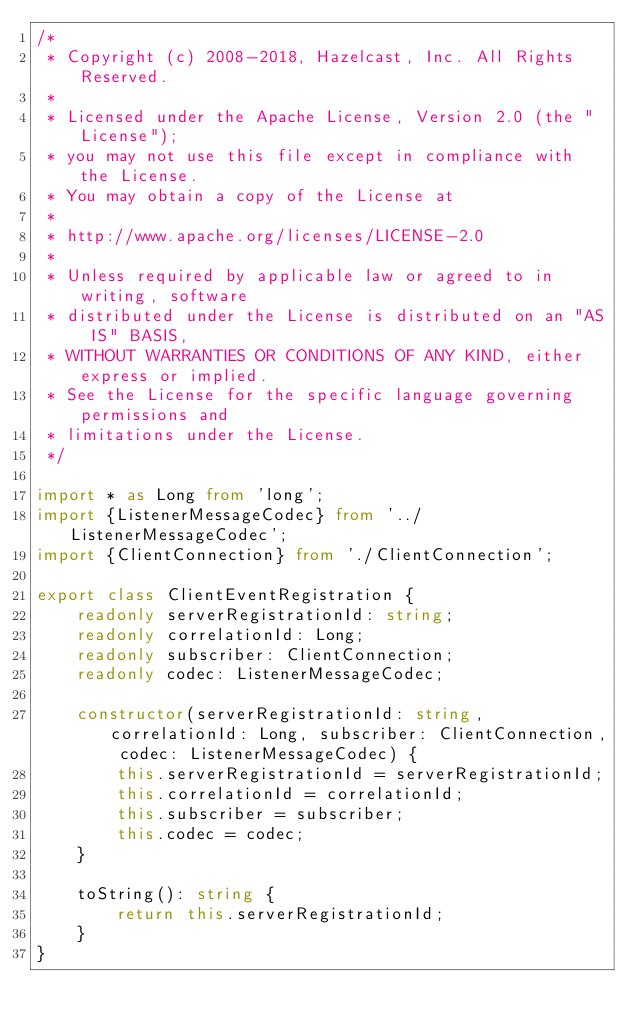Convert code to text. <code><loc_0><loc_0><loc_500><loc_500><_TypeScript_>/*
 * Copyright (c) 2008-2018, Hazelcast, Inc. All Rights Reserved.
 *
 * Licensed under the Apache License, Version 2.0 (the "License");
 * you may not use this file except in compliance with the License.
 * You may obtain a copy of the License at
 *
 * http://www.apache.org/licenses/LICENSE-2.0
 *
 * Unless required by applicable law or agreed to in writing, software
 * distributed under the License is distributed on an "AS IS" BASIS,
 * WITHOUT WARRANTIES OR CONDITIONS OF ANY KIND, either express or implied.
 * See the License for the specific language governing permissions and
 * limitations under the License.
 */

import * as Long from 'long';
import {ListenerMessageCodec} from '../ListenerMessageCodec';
import {ClientConnection} from './ClientConnection';

export class ClientEventRegistration {
    readonly serverRegistrationId: string;
    readonly correlationId: Long;
    readonly subscriber: ClientConnection;
    readonly codec: ListenerMessageCodec;

    constructor(serverRegistrationId: string, correlationId: Long, subscriber: ClientConnection, codec: ListenerMessageCodec) {
        this.serverRegistrationId = serverRegistrationId;
        this.correlationId = correlationId;
        this.subscriber = subscriber;
        this.codec = codec;
    }

    toString(): string {
        return this.serverRegistrationId;
    }
}
</code> 